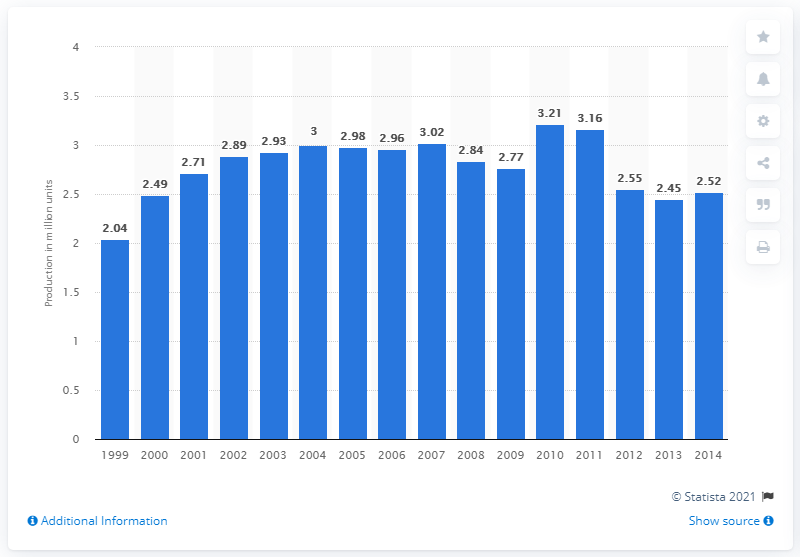Highlight a few significant elements in this photo. In 2013, PSA Peugeot Citroen of France produced 2,450 passenger vehicles. 